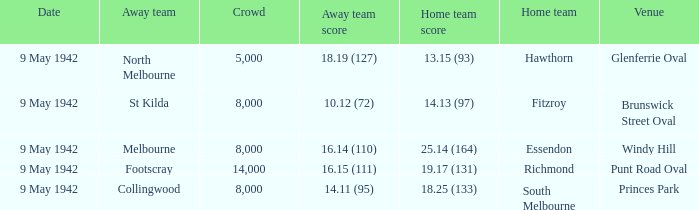How many people attended the game where Footscray was away? 14000.0. 